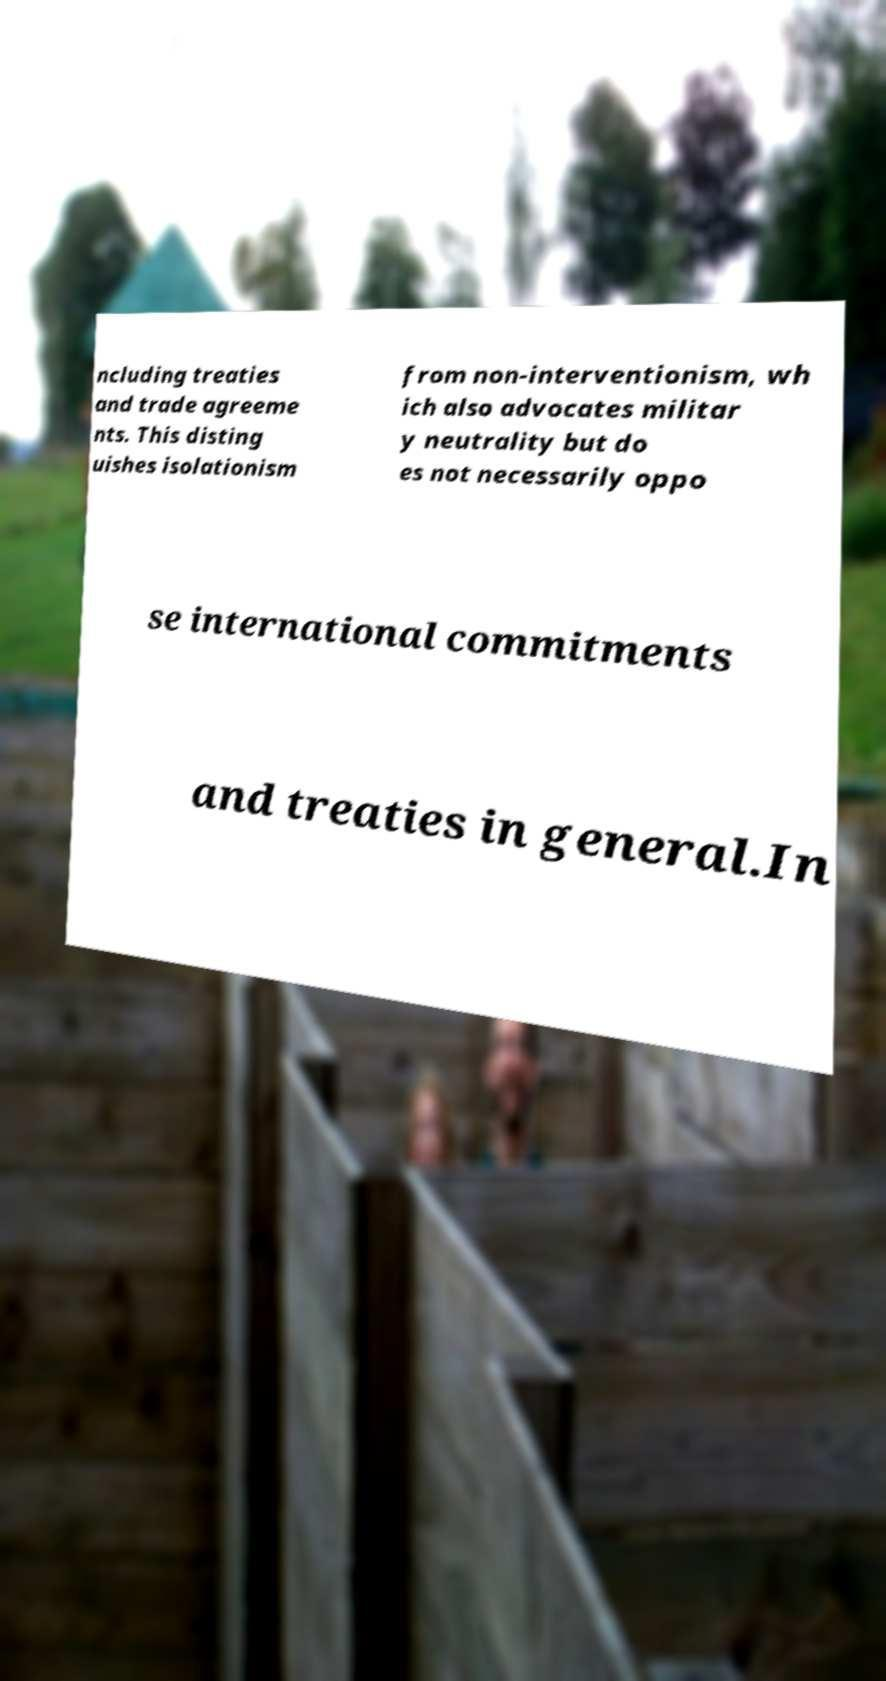What messages or text are displayed in this image? I need them in a readable, typed format. ncluding treaties and trade agreeme nts. This disting uishes isolationism from non-interventionism, wh ich also advocates militar y neutrality but do es not necessarily oppo se international commitments and treaties in general.In 